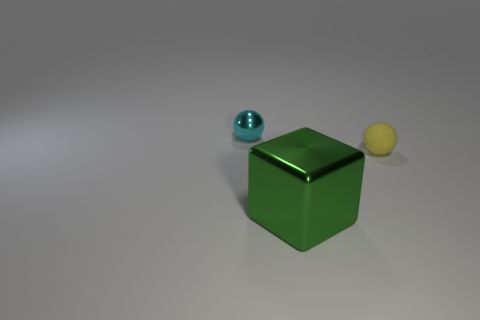How many things are purple metal spheres or balls that are to the right of the large cube?
Offer a very short reply. 1. What is the shape of the cyan metal thing?
Ensure brevity in your answer.  Sphere. Is the color of the large object the same as the small shiny thing?
Ensure brevity in your answer.  No. What is the color of the shiny object that is the same size as the matte thing?
Make the answer very short. Cyan. How many cyan things are metallic blocks or tiny metallic balls?
Ensure brevity in your answer.  1. Is the number of tiny rubber balls greater than the number of cylinders?
Your answer should be compact. Yes. There is a ball that is to the right of the small shiny ball; is it the same size as the metal object to the left of the large green metal object?
Offer a terse response. Yes. What is the color of the matte sphere in front of the small sphere left of the shiny thing in front of the small cyan metal ball?
Give a very brief answer. Yellow. Are there any tiny brown matte things that have the same shape as the green metal thing?
Your answer should be very brief. No. Are there more objects that are behind the large green object than brown objects?
Offer a very short reply. Yes. 